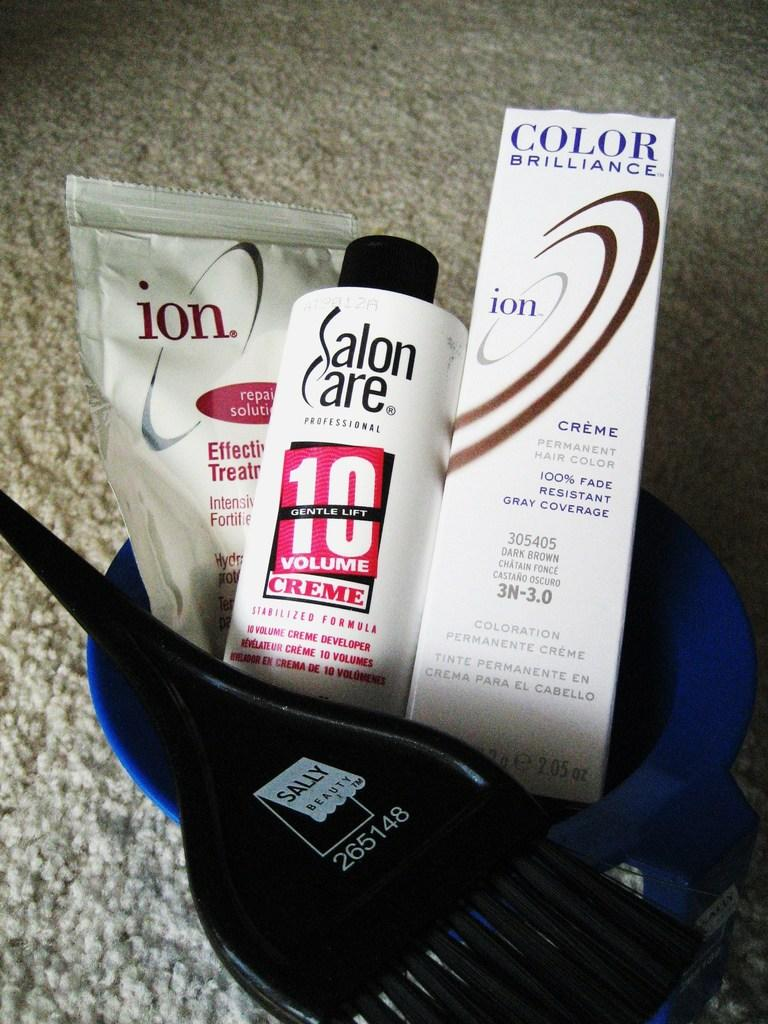<image>
Render a clear and concise summary of the photo. A blue cup with color brilliance and salon care creme and a sally pick 